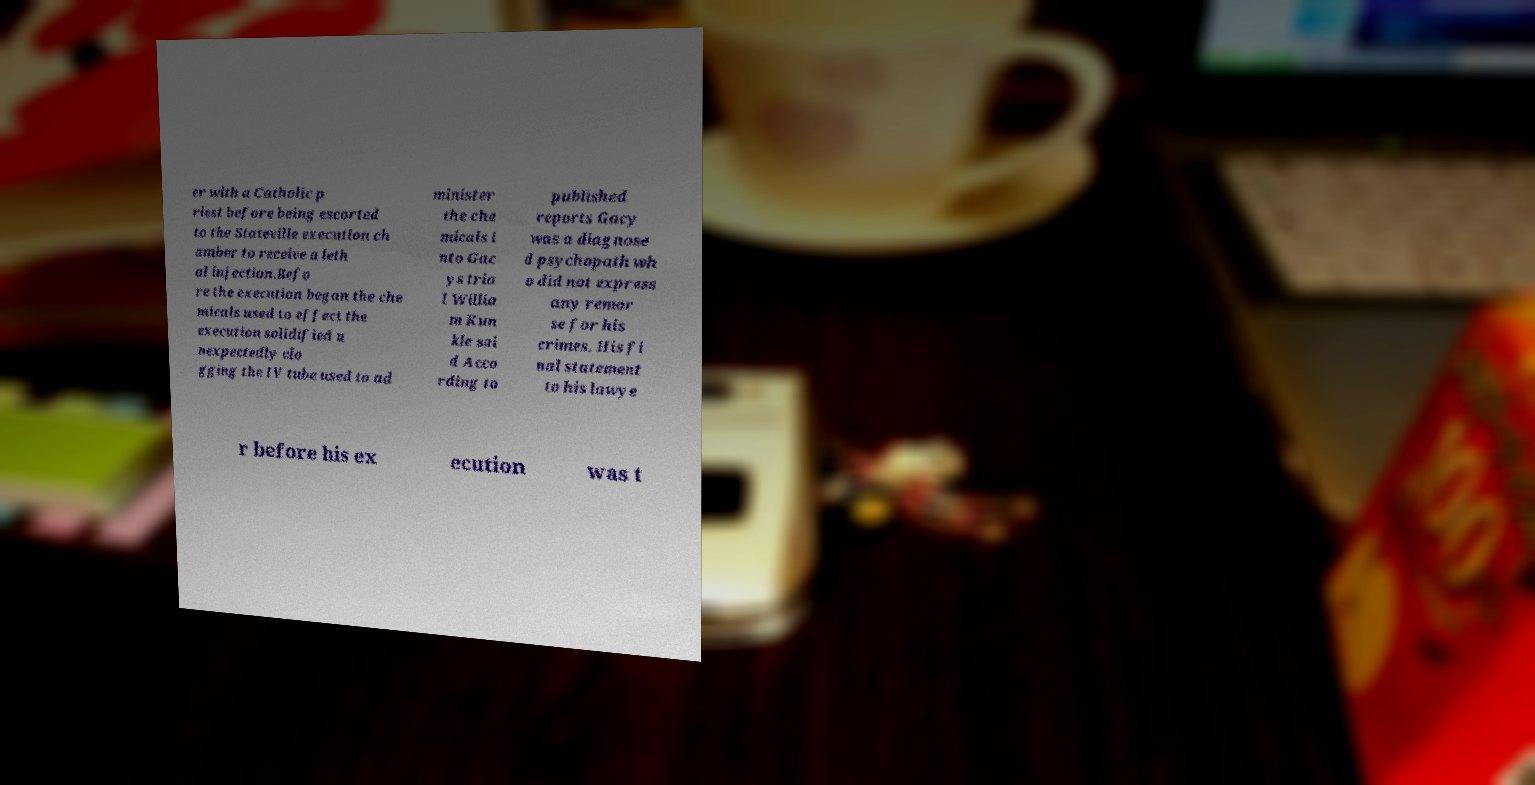Please identify and transcribe the text found in this image. er with a Catholic p riest before being escorted to the Stateville execution ch amber to receive a leth al injection.Befo re the execution began the che micals used to effect the execution solidified u nexpectedly clo gging the IV tube used to ad minister the che micals i nto Gac ys tria l Willia m Kun kle sai d Acco rding to published reports Gacy was a diagnose d psychopath wh o did not express any remor se for his crimes. His fi nal statement to his lawye r before his ex ecution was t 